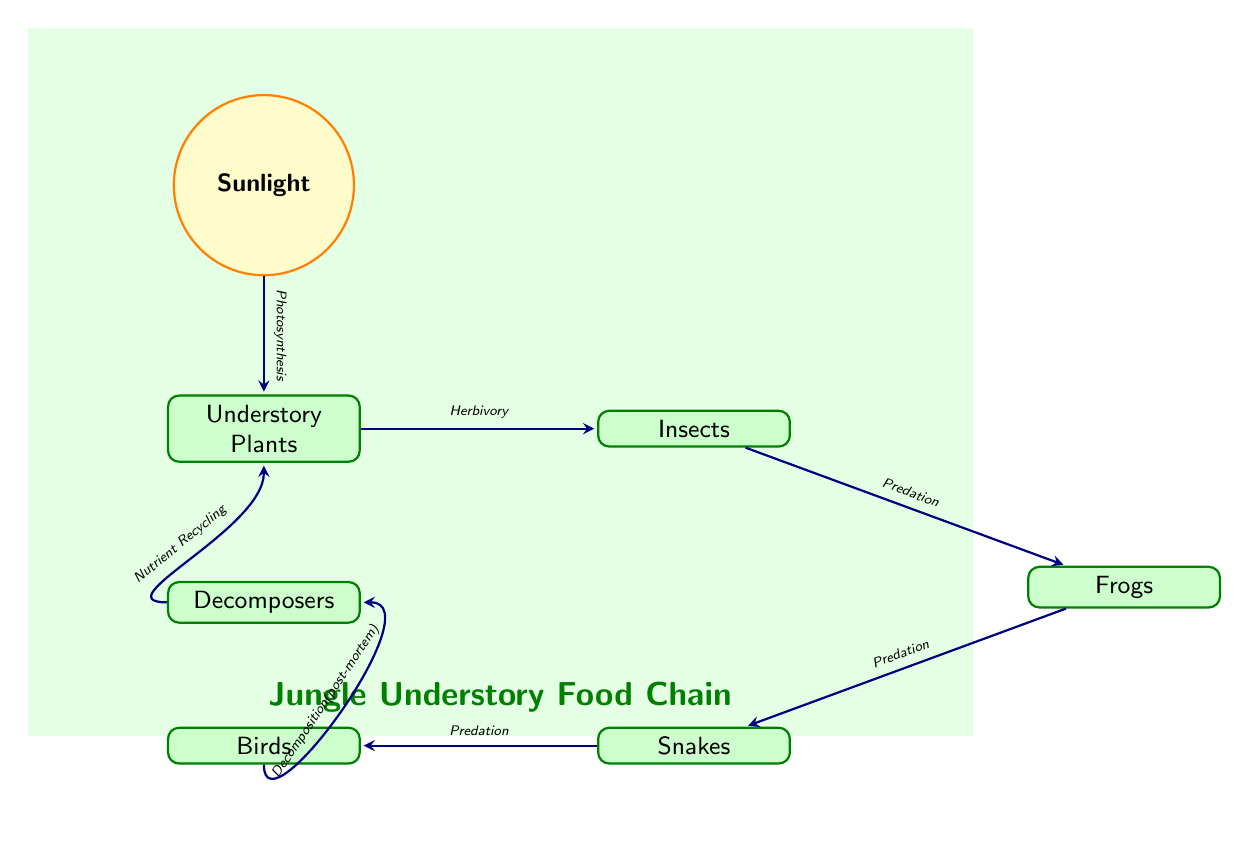What is the base of the food chain? The base of the food chain is represented by the first node, which is 'Sunlight', providing energy for the ecosystem.
Answer: Sunlight How many organisms directly consume understory plants? In the diagram, there is one organism directly consuming understory plants, which is 'Insects', connected with an arrow indicating herbivory.
Answer: 1 What comes after frogs in the food chain? Following 'Frogs', the next organism in the food chain is 'Snakes', indicated by an arrow representing predation.
Answer: Snakes How many different types of organisms are present in the food chain? The diagram shows five different types of organisms: 'Understory Plants', 'Insects', 'Frogs', 'Snakes', and 'Birds'. Counting these provides the answer.
Answer: 5 What process do decomposers contribute to? Decomposers contribute to 'Nutrient Recycling', which is shown by the arrow flowing back to 'Understory Plants', indicating they play a role in recycling nutrients back into the ecosystem.
Answer: Nutrient Recycling What is the function of sunlight in the food chain? 'Sunlight' serves the essential role of energy source, as indicated by the process of 'Photosynthesis' that connects it to 'Understory Plants'.
Answer: Photosynthesis Which organism is at the top of the food chain? The organism at the top of the food chain is 'Birds', as it is the final organism indicated by the flow of arrows in the diagram.
Answer: Birds How do birds contribute to the food chain after death? After death, 'Birds' contribute to 'Decomposition (post-mortem)', indicating their role in the ecosystem even after they are no longer alive, as shown in the diagram.
Answer: Decomposition (post-mortem) 